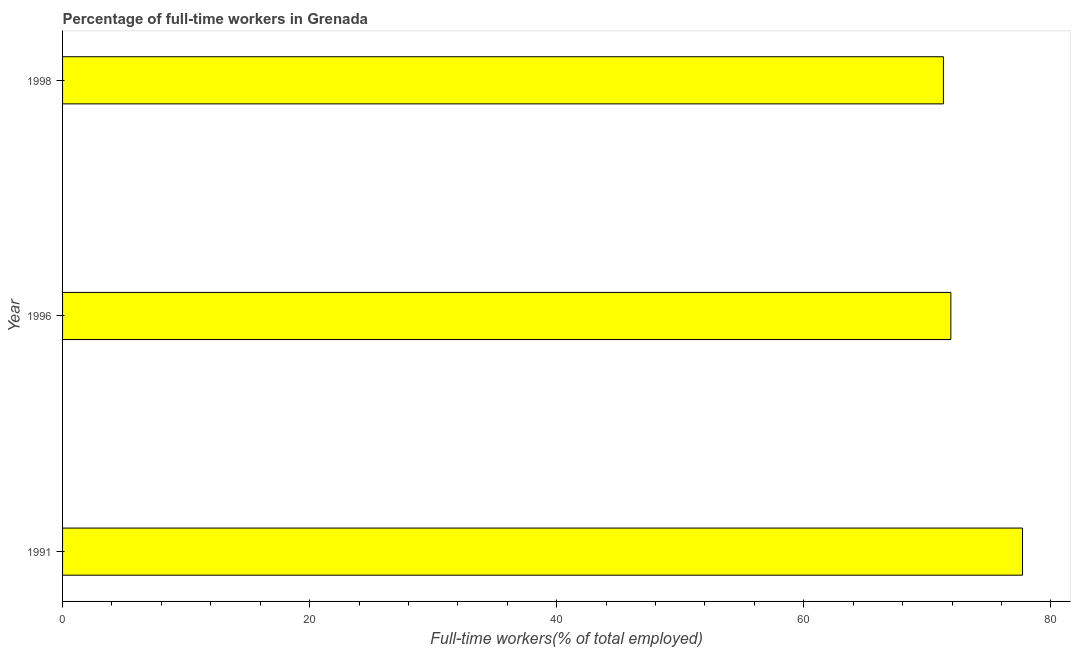Does the graph contain any zero values?
Keep it short and to the point. No. What is the title of the graph?
Give a very brief answer. Percentage of full-time workers in Grenada. What is the label or title of the X-axis?
Your answer should be very brief. Full-time workers(% of total employed). What is the label or title of the Y-axis?
Provide a succinct answer. Year. What is the percentage of full-time workers in 1996?
Make the answer very short. 71.9. Across all years, what is the maximum percentage of full-time workers?
Provide a succinct answer. 77.7. Across all years, what is the minimum percentage of full-time workers?
Provide a succinct answer. 71.3. In which year was the percentage of full-time workers minimum?
Provide a succinct answer. 1998. What is the sum of the percentage of full-time workers?
Give a very brief answer. 220.9. What is the difference between the percentage of full-time workers in 1991 and 1996?
Offer a very short reply. 5.8. What is the average percentage of full-time workers per year?
Keep it short and to the point. 73.63. What is the median percentage of full-time workers?
Keep it short and to the point. 71.9. What is the ratio of the percentage of full-time workers in 1996 to that in 1998?
Your response must be concise. 1.01. Is the percentage of full-time workers in 1991 less than that in 1998?
Make the answer very short. No. Is the difference between the percentage of full-time workers in 1991 and 1996 greater than the difference between any two years?
Keep it short and to the point. No. Is the sum of the percentage of full-time workers in 1996 and 1998 greater than the maximum percentage of full-time workers across all years?
Offer a very short reply. Yes. What is the difference between the highest and the lowest percentage of full-time workers?
Offer a very short reply. 6.4. How many bars are there?
Provide a short and direct response. 3. Are the values on the major ticks of X-axis written in scientific E-notation?
Your answer should be compact. No. What is the Full-time workers(% of total employed) in 1991?
Keep it short and to the point. 77.7. What is the Full-time workers(% of total employed) in 1996?
Your answer should be very brief. 71.9. What is the Full-time workers(% of total employed) of 1998?
Offer a terse response. 71.3. What is the difference between the Full-time workers(% of total employed) in 1991 and 1998?
Give a very brief answer. 6.4. What is the difference between the Full-time workers(% of total employed) in 1996 and 1998?
Offer a terse response. 0.6. What is the ratio of the Full-time workers(% of total employed) in 1991 to that in 1996?
Make the answer very short. 1.08. What is the ratio of the Full-time workers(% of total employed) in 1991 to that in 1998?
Provide a succinct answer. 1.09. 